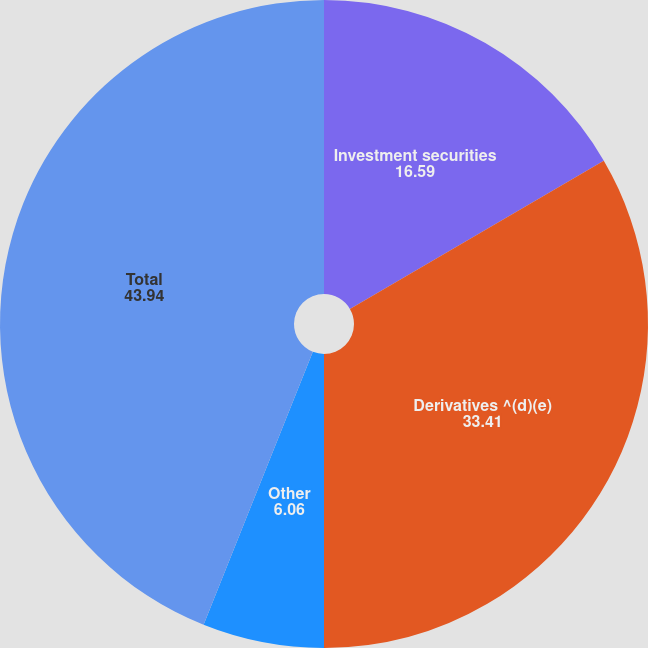Convert chart to OTSL. <chart><loc_0><loc_0><loc_500><loc_500><pie_chart><fcel>Investment securities<fcel>Derivatives ^(d)(e)<fcel>Other<fcel>Total<nl><fcel>16.59%<fcel>33.41%<fcel>6.06%<fcel>43.94%<nl></chart> 